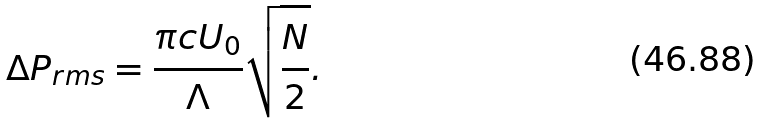Convert formula to latex. <formula><loc_0><loc_0><loc_500><loc_500>\Delta P _ { r m s } = \frac { \pi c U _ { 0 } } { \Lambda } \sqrt { \frac { N } { 2 } } .</formula> 